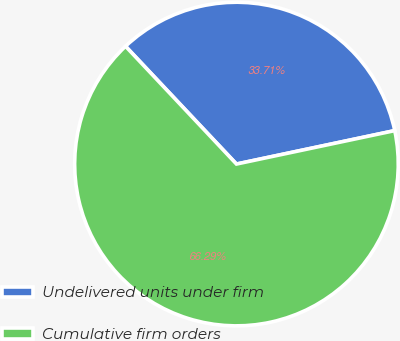Convert chart to OTSL. <chart><loc_0><loc_0><loc_500><loc_500><pie_chart><fcel>Undelivered units under firm<fcel>Cumulative firm orders<nl><fcel>33.71%<fcel>66.29%<nl></chart> 